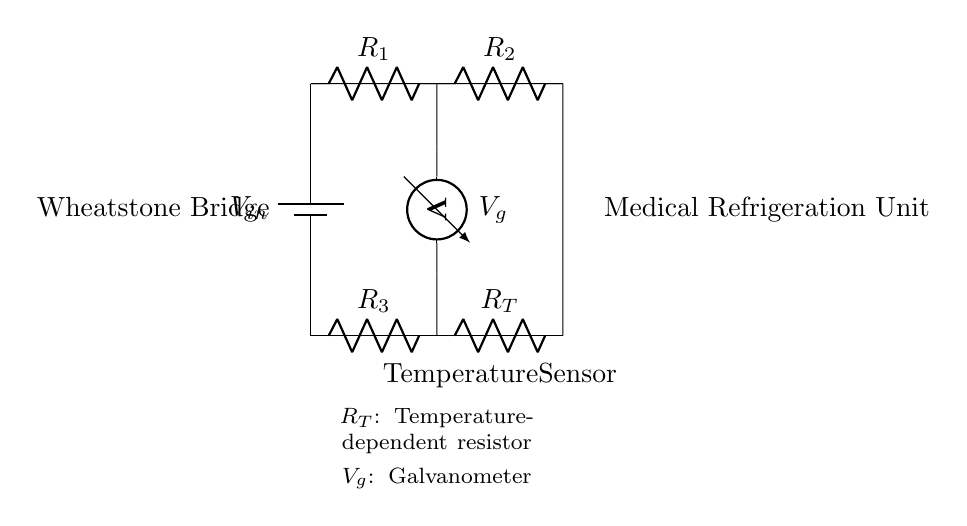What is the input voltage of the Wheatstone bridge? The input voltage is indicated as "V_in" connected to the battery on the left side of the circuit.
Answer: V_in What are the resistors in the Wheatstone bridge labeled as? The resistors are labeled as R_1, R_2, R_3, and R_T, positioned in specific locations within the circuit.
Answer: R_1, R_2, R_3, R_T What does the voltage V_g represent in the circuit? V_g is the voltage across the galvanometer, connected between the two junctions of R_1 & R_2 and R_3 & R_T, indicating the unbalance in the bridge.
Answer: Galvanometer voltage What would happen to V_g if R_T increases due to a temperature rise? If R_T increases, the bridge might become unbalanced, leading to a change in the voltage V_g, indicating a temperature rise which is crucial for monitoring in medical refrigeration.
Answer: Increase How can you determine if the Wheatstone bridge is balanced? The bridge is balanced when the voltages across the galvanometer (V_g) read zero, implying that R_1/R_2 equals R_3/R_T, indicating no current flows through the galvanometer.
Answer: No current through galvanometer What is the function of R_T in the context of this circuit? R_T serves as the temperature sensor whose resistance changes with temperature, allowing the bridge to detect variations in temperature for accurate measurement in medical refrigeration.
Answer: Temperature sensor What type of circuit is this diagram illustrating? This diagram illustrates a Wheatstone bridge circuit, which is used for measuring unknown resistances and can provide precise measurements for temperature monitoring applications.
Answer: Wheatstone bridge 